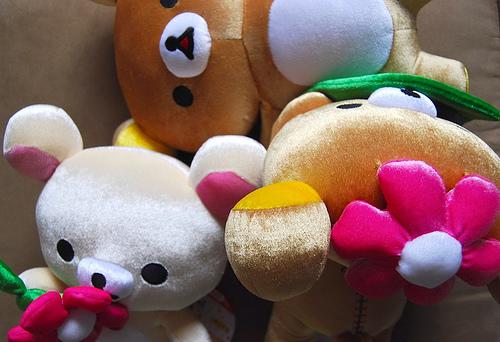Are these toys all the same?
Give a very brief answer. No. Do the toys look new?
Quick response, please. Yes. How many toys are there?
Short answer required. 3. How many toys are in this picture?
Be succinct. 3. 